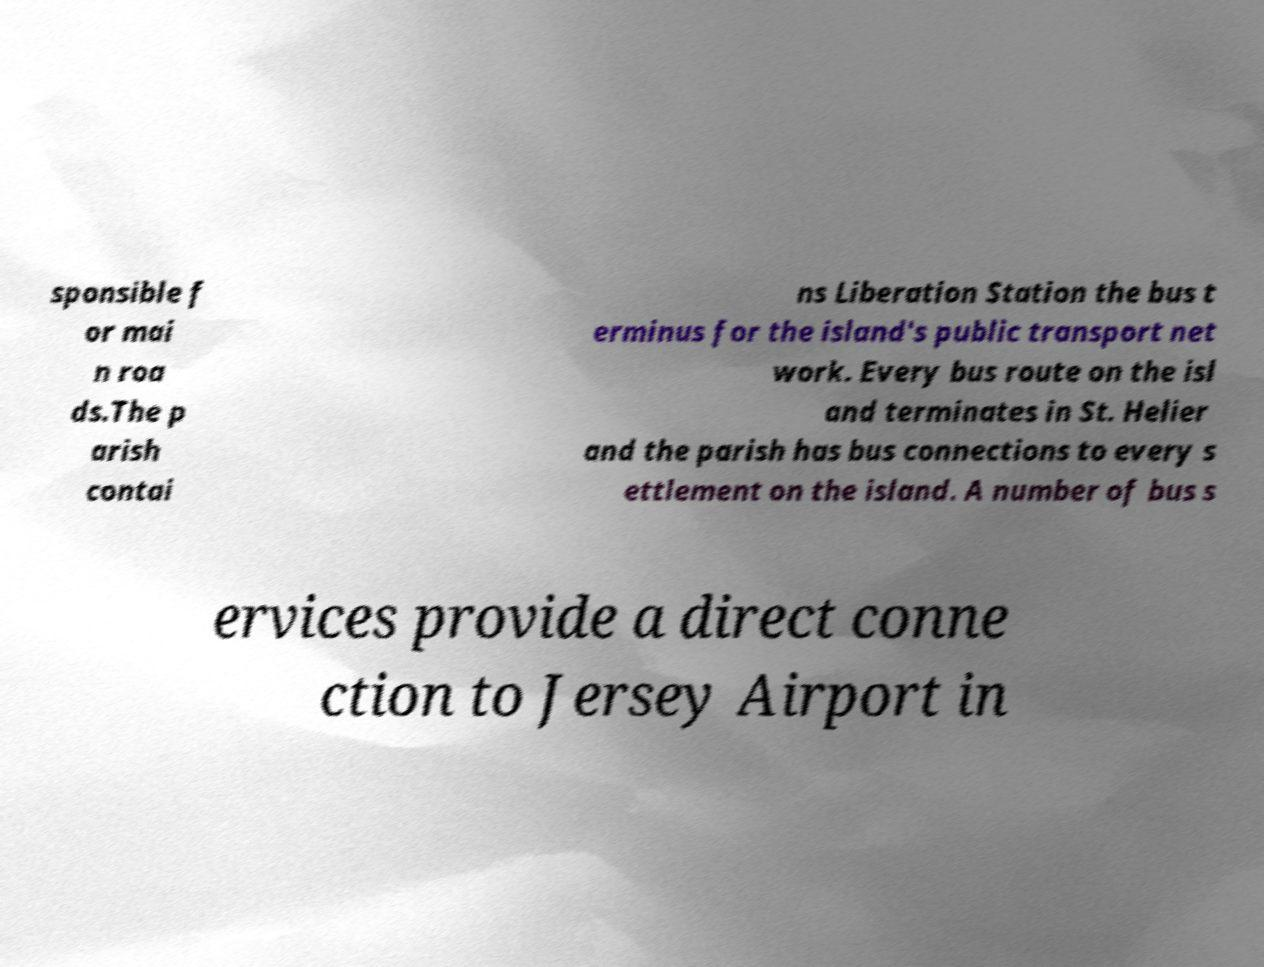For documentation purposes, I need the text within this image transcribed. Could you provide that? sponsible f or mai n roa ds.The p arish contai ns Liberation Station the bus t erminus for the island's public transport net work. Every bus route on the isl and terminates in St. Helier and the parish has bus connections to every s ettlement on the island. A number of bus s ervices provide a direct conne ction to Jersey Airport in 